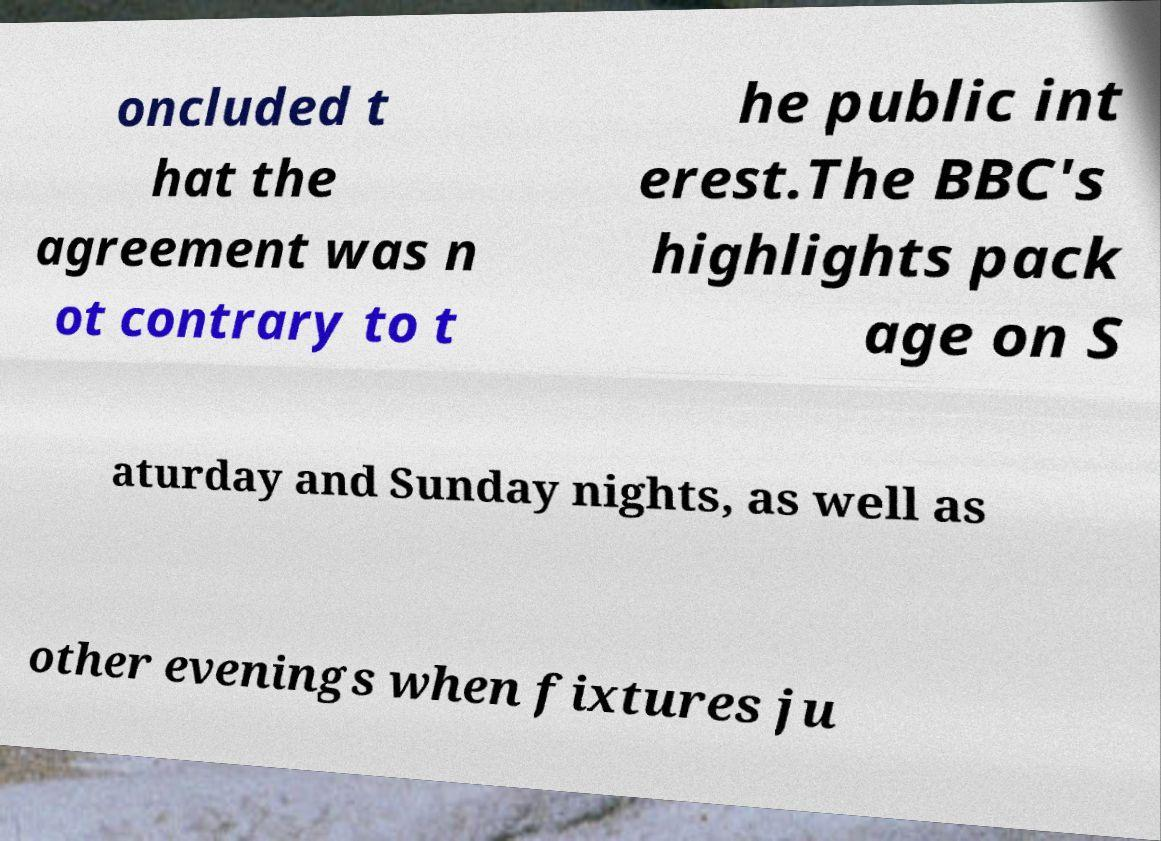Please identify and transcribe the text found in this image. oncluded t hat the agreement was n ot contrary to t he public int erest.The BBC's highlights pack age on S aturday and Sunday nights, as well as other evenings when fixtures ju 